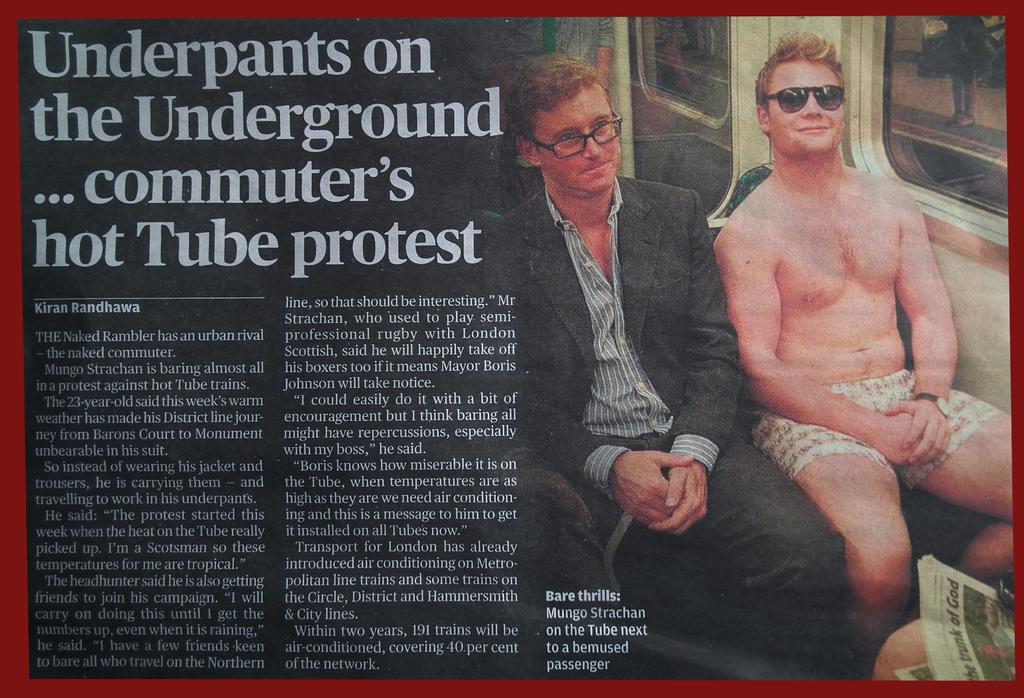How many people are sitting in the image? There are two persons sitting in the image. What is the person on the left wearing? The person on the left is wearing a black color blazer and a gray color shirt. What else can be seen in the image besides the two persons? There is text or writing visible in the image. What role does the actor play in the image? There is no actor present in the image, so it is not possible to determine the role they might play. 